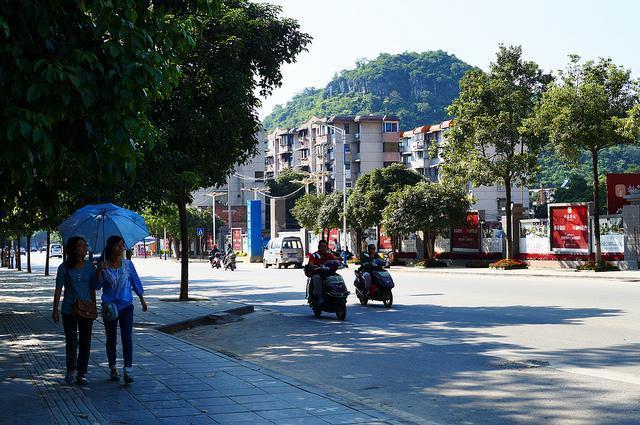How many motor scooters are in the scene?
Give a very brief answer. 2. How many people are under the umbrella?
Give a very brief answer. 2. How many feet are touching the ground of the man riding the motorcycle?
Give a very brief answer. 0. How many people are in the photo?
Give a very brief answer. 2. How many brown horses are jumping in this photo?
Give a very brief answer. 0. 